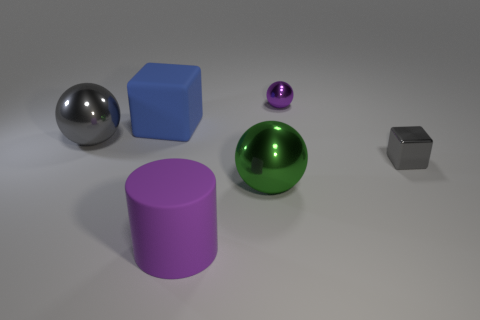Add 3 red metallic cubes. How many objects exist? 9 Subtract all cylinders. How many objects are left? 5 Subtract all purple balls. Subtract all purple rubber cylinders. How many objects are left? 4 Add 5 big things. How many big things are left? 9 Add 2 balls. How many balls exist? 5 Subtract 0 gray cylinders. How many objects are left? 6 